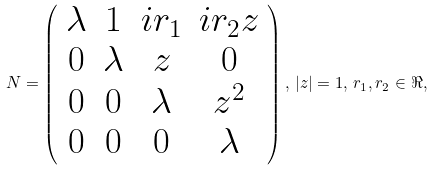<formula> <loc_0><loc_0><loc_500><loc_500>N = \left ( \begin{array} { c c c c } \lambda & 1 & i r _ { 1 } & i r _ { 2 } z \\ 0 & \lambda & z & 0 \\ 0 & 0 & \lambda & z ^ { 2 } \\ 0 & 0 & 0 & \lambda \end{array} \right ) , \, | z | = 1 , \, r _ { 1 } , r _ { 2 } \in \Re ,</formula> 